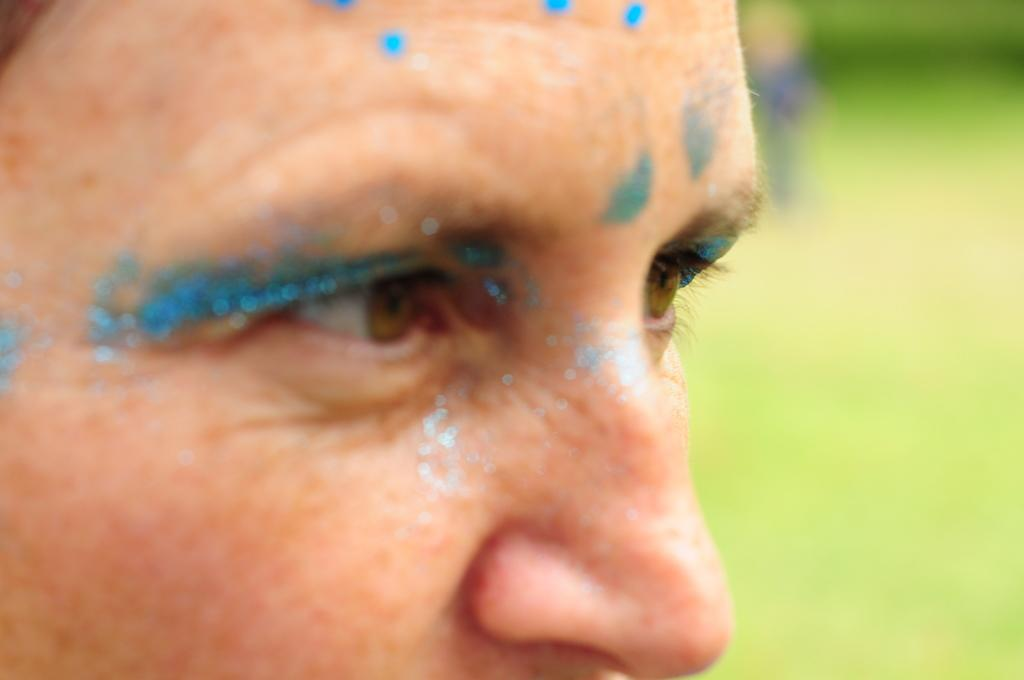What is on the face of the person in the image? There is glitter on the face of a person in the image. How would you describe the background of the image? The background of the image is blurred. What type of plant is growing on the person's shoulder in the image? There is no plant visible on the person's shoulder in the image. 